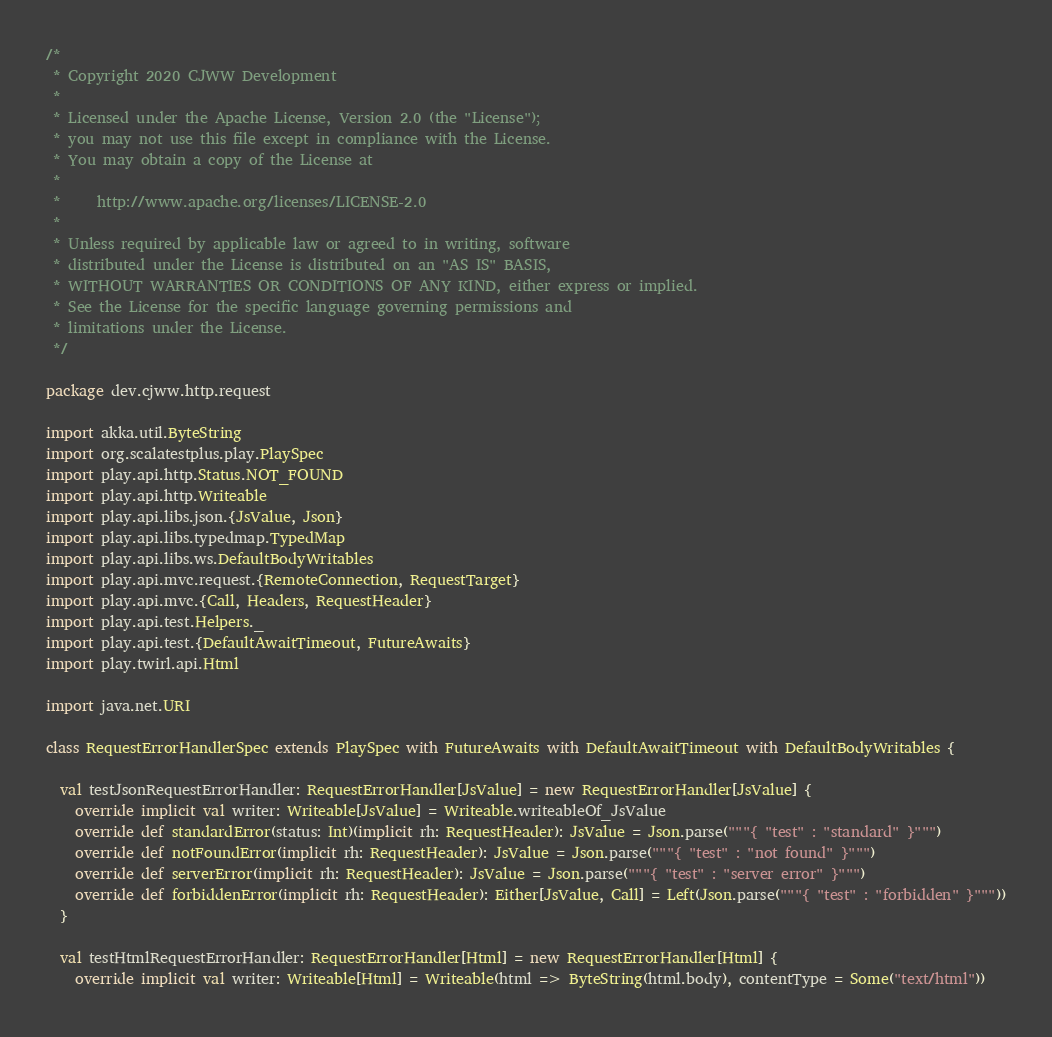Convert code to text. <code><loc_0><loc_0><loc_500><loc_500><_Scala_>/*
 * Copyright 2020 CJWW Development
 *
 * Licensed under the Apache License, Version 2.0 (the "License");
 * you may not use this file except in compliance with the License.
 * You may obtain a copy of the License at
 *
 *     http://www.apache.org/licenses/LICENSE-2.0
 *
 * Unless required by applicable law or agreed to in writing, software
 * distributed under the License is distributed on an "AS IS" BASIS,
 * WITHOUT WARRANTIES OR CONDITIONS OF ANY KIND, either express or implied.
 * See the License for the specific language governing permissions and
 * limitations under the License.
 */

package dev.cjww.http.request

import akka.util.ByteString
import org.scalatestplus.play.PlaySpec
import play.api.http.Status.NOT_FOUND
import play.api.http.Writeable
import play.api.libs.json.{JsValue, Json}
import play.api.libs.typedmap.TypedMap
import play.api.libs.ws.DefaultBodyWritables
import play.api.mvc.request.{RemoteConnection, RequestTarget}
import play.api.mvc.{Call, Headers, RequestHeader}
import play.api.test.Helpers._
import play.api.test.{DefaultAwaitTimeout, FutureAwaits}
import play.twirl.api.Html

import java.net.URI

class RequestErrorHandlerSpec extends PlaySpec with FutureAwaits with DefaultAwaitTimeout with DefaultBodyWritables {

  val testJsonRequestErrorHandler: RequestErrorHandler[JsValue] = new RequestErrorHandler[JsValue] {
    override implicit val writer: Writeable[JsValue] = Writeable.writeableOf_JsValue
    override def standardError(status: Int)(implicit rh: RequestHeader): JsValue = Json.parse("""{ "test" : "standard" }""")
    override def notFoundError(implicit rh: RequestHeader): JsValue = Json.parse("""{ "test" : "not found" }""")
    override def serverError(implicit rh: RequestHeader): JsValue = Json.parse("""{ "test" : "server error" }""")
    override def forbiddenError(implicit rh: RequestHeader): Either[JsValue, Call] = Left(Json.parse("""{ "test" : "forbidden" }"""))
  }

  val testHtmlRequestErrorHandler: RequestErrorHandler[Html] = new RequestErrorHandler[Html] {
    override implicit val writer: Writeable[Html] = Writeable(html => ByteString(html.body), contentType = Some("text/html"))</code> 